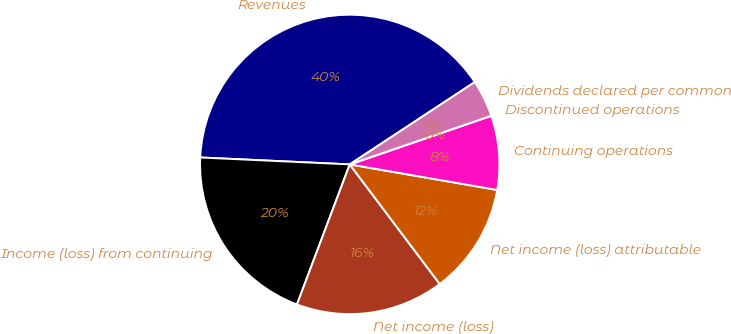Convert chart. <chart><loc_0><loc_0><loc_500><loc_500><pie_chart><fcel>Revenues<fcel>Income (loss) from continuing<fcel>Net income (loss)<fcel>Net income (loss) attributable<fcel>Continuing operations<fcel>Discontinued operations<fcel>Dividends declared per common<nl><fcel>40.0%<fcel>20.0%<fcel>16.0%<fcel>12.0%<fcel>8.0%<fcel>0.0%<fcel>4.0%<nl></chart> 